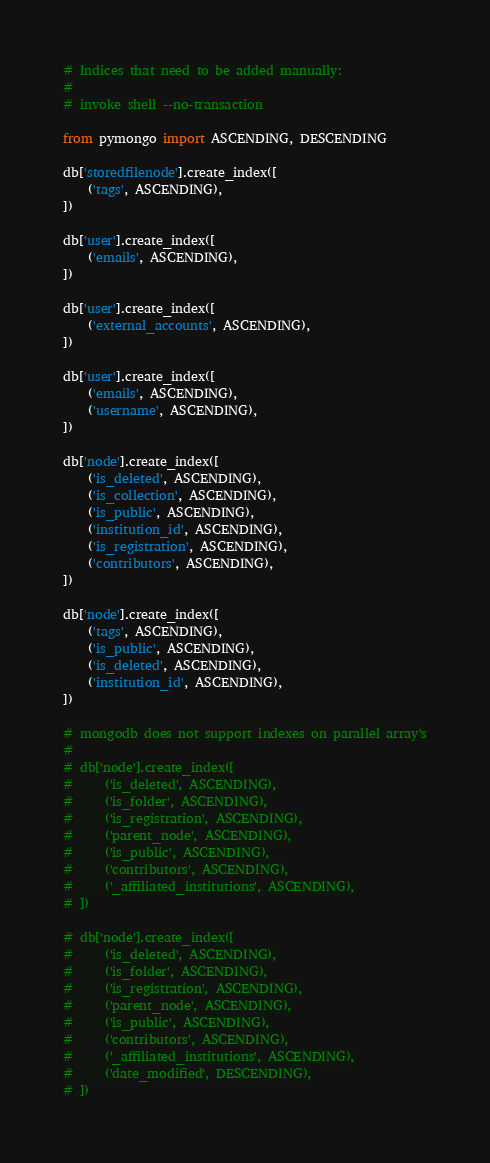Convert code to text. <code><loc_0><loc_0><loc_500><loc_500><_Python_># Indices that need to be added manually:
#
# invoke shell --no-transaction

from pymongo import ASCENDING, DESCENDING

db['storedfilenode'].create_index([
    ('tags', ASCENDING),
])

db['user'].create_index([
    ('emails', ASCENDING),
])

db['user'].create_index([
    ('external_accounts', ASCENDING),
])

db['user'].create_index([
    ('emails', ASCENDING),
    ('username', ASCENDING),
])

db['node'].create_index([
    ('is_deleted', ASCENDING),
    ('is_collection', ASCENDING),
    ('is_public', ASCENDING),
    ('institution_id', ASCENDING),
    ('is_registration', ASCENDING),
    ('contributors', ASCENDING),
])

db['node'].create_index([
    ('tags', ASCENDING),
    ('is_public', ASCENDING),
    ('is_deleted', ASCENDING),
    ('institution_id', ASCENDING),
])

# mongodb does not support indexes on parallel array's
#
# db['node'].create_index([
#     ('is_deleted', ASCENDING),
#     ('is_folder', ASCENDING),
#     ('is_registration', ASCENDING),
#     ('parent_node', ASCENDING),
#     ('is_public', ASCENDING),
#     ('contributors', ASCENDING),
#     ('_affiliated_institutions', ASCENDING),
# ])

# db['node'].create_index([
#     ('is_deleted', ASCENDING),
#     ('is_folder', ASCENDING),
#     ('is_registration', ASCENDING),
#     ('parent_node', ASCENDING),
#     ('is_public', ASCENDING),
#     ('contributors', ASCENDING),
#     ('_affiliated_institutions', ASCENDING),
#     ('date_modified', DESCENDING),
# ])
</code> 